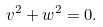Convert formula to latex. <formula><loc_0><loc_0><loc_500><loc_500>v ^ { 2 } + w ^ { 2 } = 0 .</formula> 